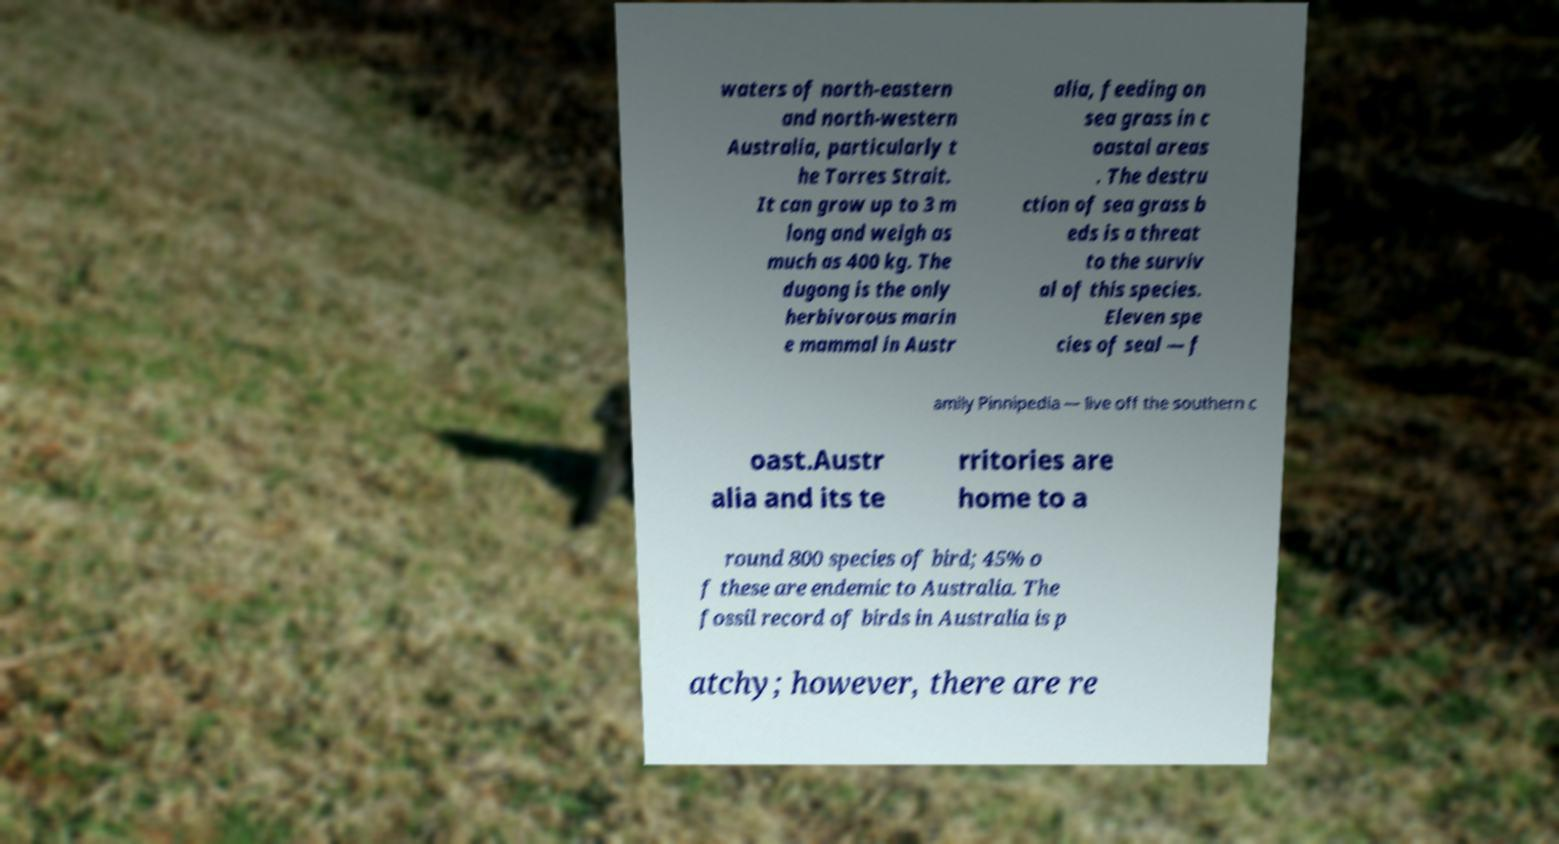Could you extract and type out the text from this image? waters of north-eastern and north-western Australia, particularly t he Torres Strait. It can grow up to 3 m long and weigh as much as 400 kg. The dugong is the only herbivorous marin e mammal in Austr alia, feeding on sea grass in c oastal areas . The destru ction of sea grass b eds is a threat to the surviv al of this species. Eleven spe cies of seal — f amily Pinnipedia — live off the southern c oast.Austr alia and its te rritories are home to a round 800 species of bird; 45% o f these are endemic to Australia. The fossil record of birds in Australia is p atchy; however, there are re 